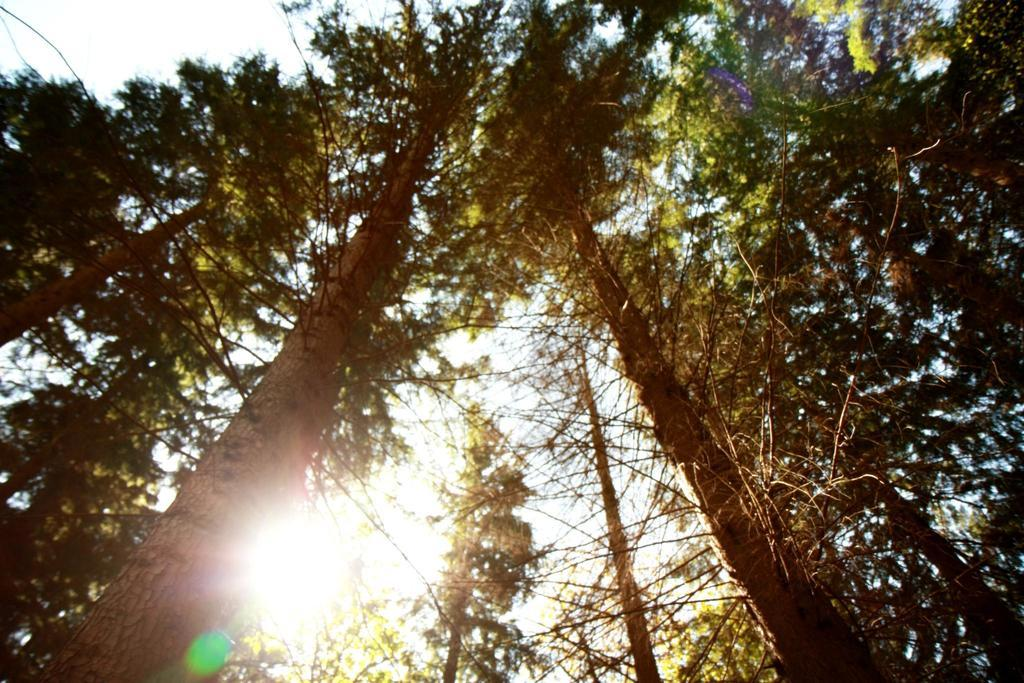What part of the natural environment is visible in the image? The sky is visible in the image. What type of vegetation can be seen in the image? There are trees in the image. Can you see any forks growing on the trees in the image? There are no forks present in the image, as forks are man-made utensils and not a type of plant that grows on trees. Is there a wishing well visible in the image? There is no wishing well present in the image. Is there a cave visible in the image? There is no cave present in the image. 